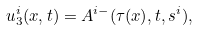<formula> <loc_0><loc_0><loc_500><loc_500>u _ { 3 } ^ { i } ( x , t ) = A ^ { i - } ( \tau ( x ) , t , s ^ { i } ) ,</formula> 